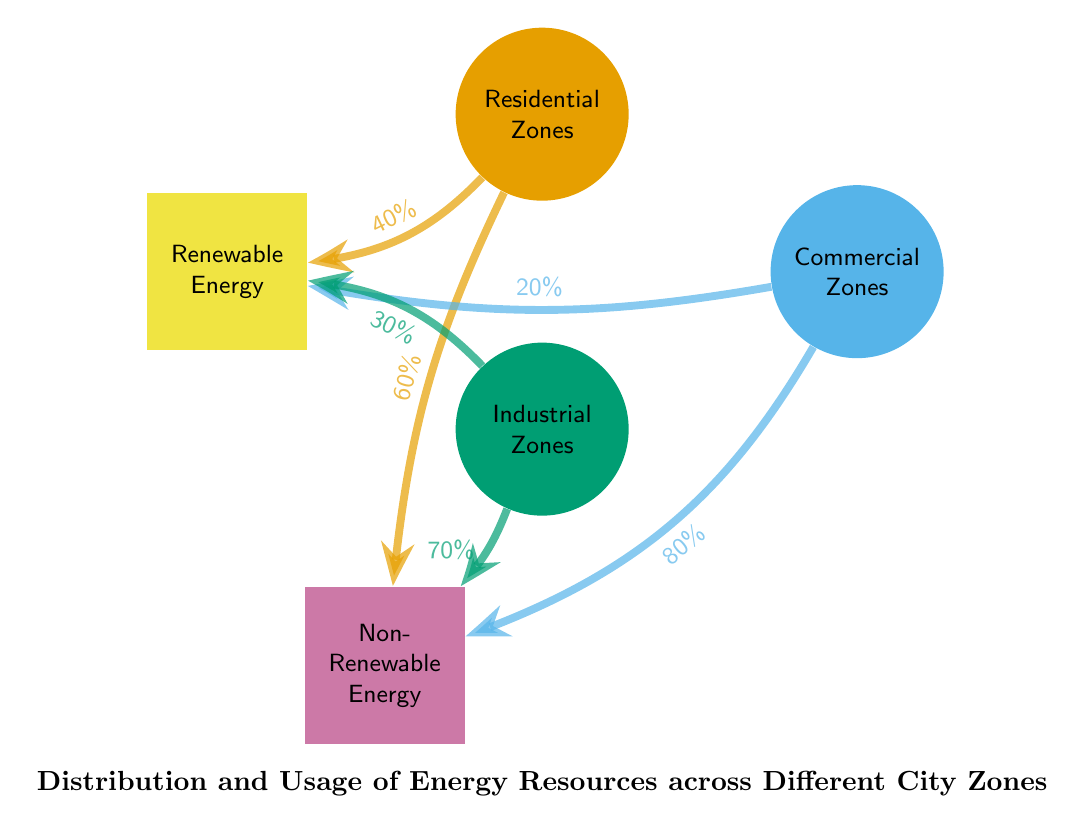What percentage of energy usage in Residential Zones comes from Renewable Energy? According to the diagram, 40% of the energy usage in Residential Zones comes from Renewable Energy, as indicated by the flow connecting Residential Zones to Renewable Energy.
Answer: 40% What is the total percentage of energy coming from Non-Renewable Energy in Commercial Zones? The diagram shows that Commercial Zones have an 80% usage of Non-Renewable Energy, which is the only connection to Non-Renewable Energy from Commercial Zones.
Answer: 80% How many energy sources are represented in this diagram? The diagram includes two energy sources: Renewable Energy and Non-Renewable Energy, as evident from the nodes labeled under energy.
Answer: 2 Which zone has the lowest percentage of energy usage from Renewable Energy? Analyzing the flows, Commercial Zones have a 20% usage of Renewable Energy, which is lower than the 30% from Industrial Zones and 40% from Residential Zones.
Answer: Commercial Zones What is the flow percentage from Industrial Zones to Non-Renewable Energy? The flow from Industrial Zones to Non-Renewable Energy is indicated as 70% in the diagram, which means that is the majority of the energy usage from that zone.
Answer: 70% If the Renewable Energy usage in Residential Zones increases by 10%, what would the new percentage be? The current usage from Renewable Energy in Residential Zones is 40%. If it increases by 10%, the calculation would be 40% + 10% = 50%.
Answer: 50% What is the combined total percentage of Renewable Energy usage across all zones? Adding up the flows: Residential Zones (40%) + Commercial Zones (20%) + Industrial Zones (30%) gives a total of 90% for Renewable Energy across all zones.
Answer: 90% Which energy source has the highest overall percentage of usage in the diagram? By examining the provided percentages, Non-Renewable Energy has a total usage of 210% (60% from Residential, 80% from Commercial, 70% from Industrial), making it the highest.
Answer: Non-Renewable Energy 